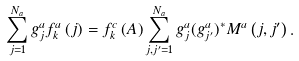Convert formula to latex. <formula><loc_0><loc_0><loc_500><loc_500>\sum _ { j = 1 } ^ { N _ { a } } g _ { j } ^ { a } f _ { k } ^ { a } \left ( j \right ) = f _ { k } ^ { c } \left ( A \right ) \sum _ { j , j ^ { \prime } = 1 } ^ { N _ { a } } g _ { j } ^ { a } ( g _ { j ^ { \prime } } ^ { a } ) ^ { \ast } M ^ { a } \left ( j , j ^ { \prime } \right ) .</formula> 